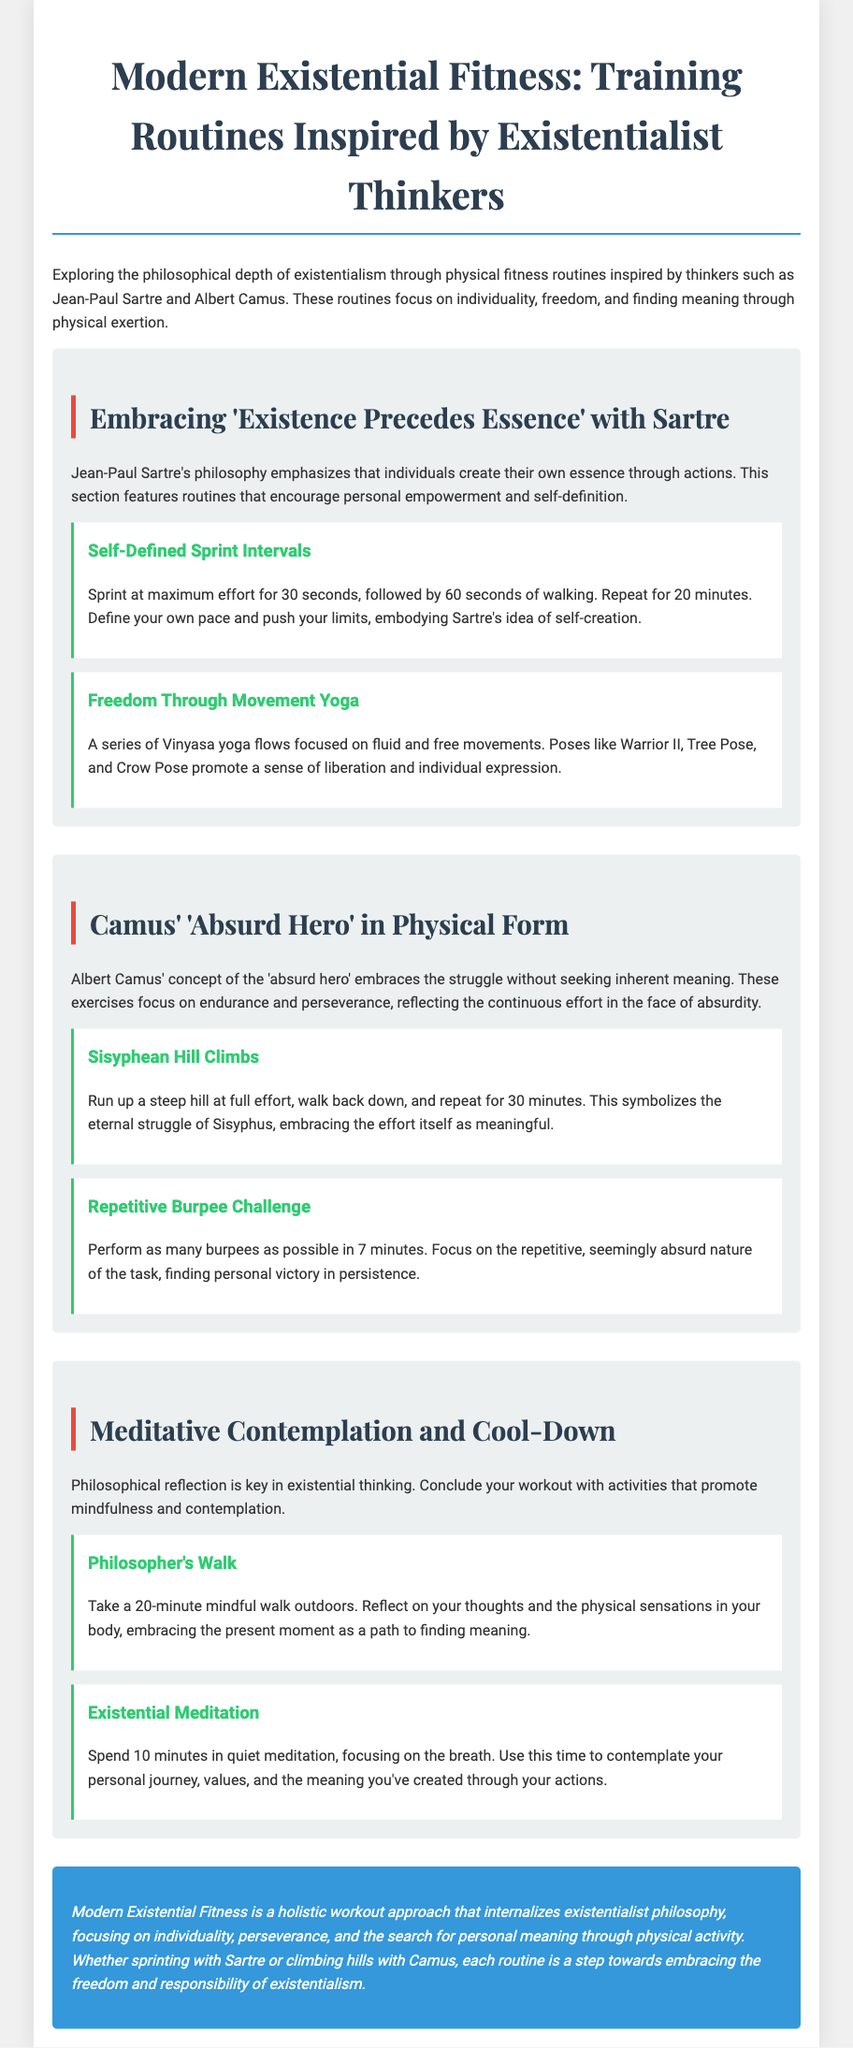What is the main theme of the document? The main theme of the document is the exploration of existentialism through fitness routines inspired by existentialist thinkers.
Answer: Modern Existential Fitness Who are the two main existentialist thinkers mentioned? The document mentions two existentialist thinkers who inspire the routines: Jean-Paul Sartre and Albert Camus.
Answer: Sartre and Camus How long should the Self-Defined Sprint Intervals last? The document states that the duration for the Self-Defined Sprint Intervals is to be repeated for 20 minutes.
Answer: 20 minutes What type of yoga is included in the routines? In the routines, the type of yoga included focuses on fluid and free movements.
Answer: Vinyasa yoga What exercise symbolizes the struggle of Sisyphus? According to the document, the exercise that symbolizes the struggle of Sisyphus is the Sisyphean Hill Climbs.
Answer: Sisyphean Hill Climbs How many minutes should be spent on Existential Meditation? The document specifies that 10 minutes should be spent on Existential Meditation.
Answer: 10 minutes What is emphasized in the conclusion of the document? The conclusion emphasizes the importance of individuality, perseverance, and the search for personal meaning.
Answer: Individuality, perseverance, meaning What is the duration of the Philosopher's Walk? The document indicates that the duration of the Philosopher's Walk is 20 minutes.
Answer: 20 minutes 